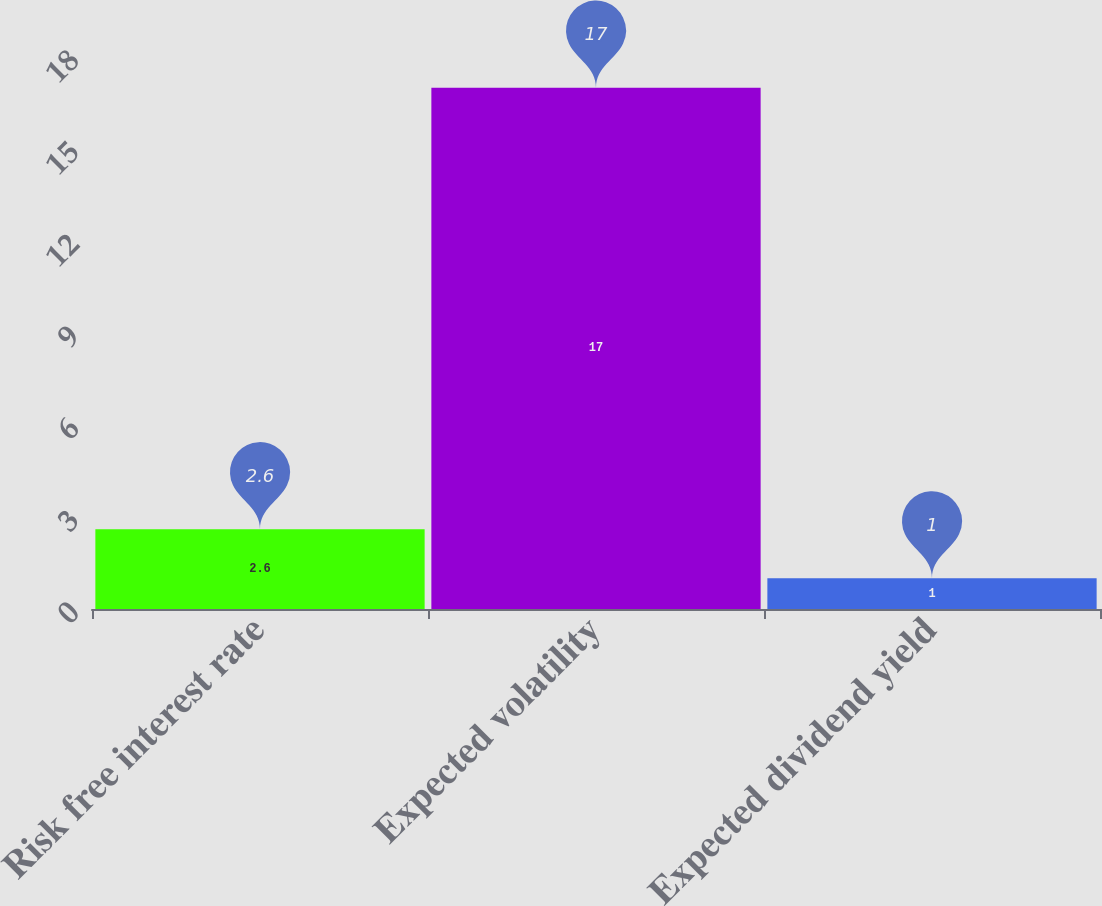Convert chart to OTSL. <chart><loc_0><loc_0><loc_500><loc_500><bar_chart><fcel>Risk free interest rate<fcel>Expected volatility<fcel>Expected dividend yield<nl><fcel>2.6<fcel>17<fcel>1<nl></chart> 